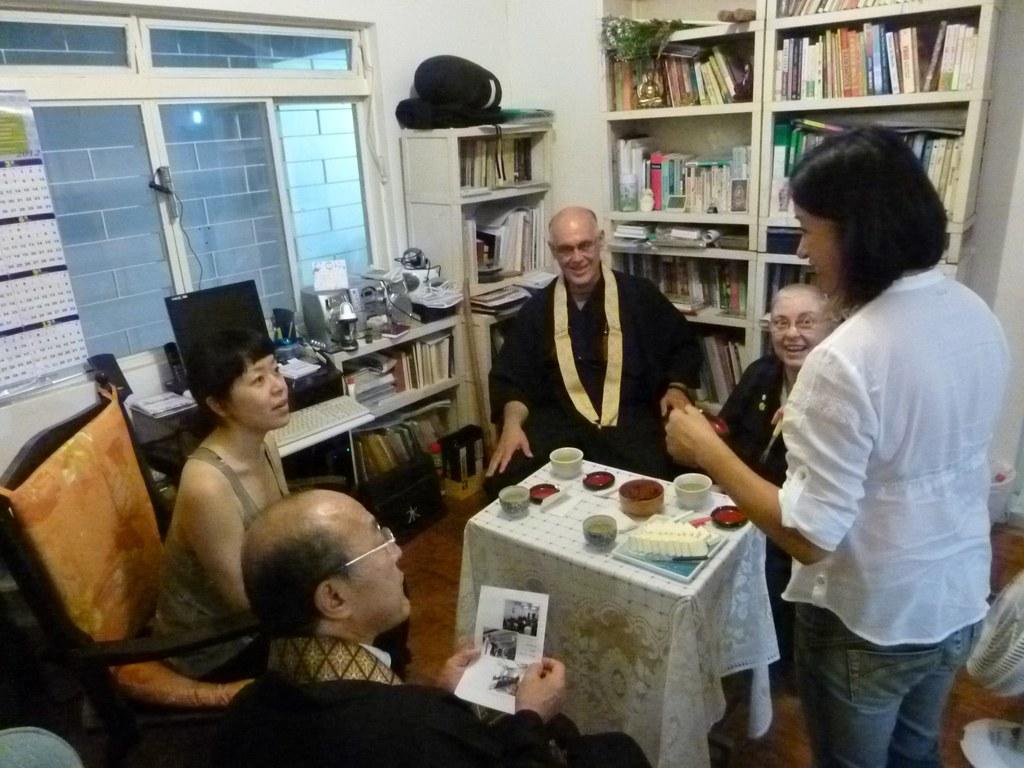Could you give a brief overview of what you see in this image? There are five people in this image, from which four are sitting and one person is standing. The woman to the right is wearing a white shirt and a blue jeans. The woman to the left is sitting on a chair in front of the table on which food is kept. In the background there is a window and cupboards filled with books and a system and also there is a calendar on the wall. 